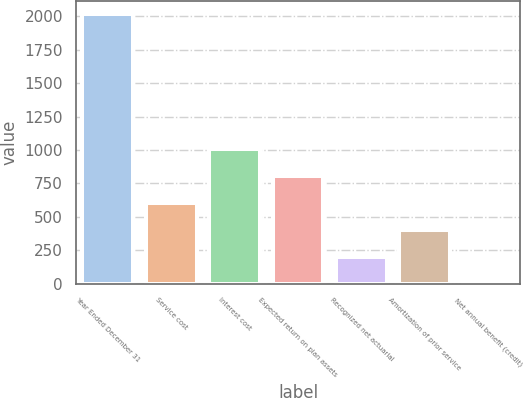Convert chart. <chart><loc_0><loc_0><loc_500><loc_500><bar_chart><fcel>Year Ended December 31<fcel>Service cost<fcel>Interest cost<fcel>Expected return on plan assets<fcel>Recognized net actuarial<fcel>Amortization of prior service<fcel>Net annual benefit (credit)<nl><fcel>2016<fcel>606.2<fcel>1009<fcel>807.6<fcel>203.4<fcel>404.8<fcel>2<nl></chart> 